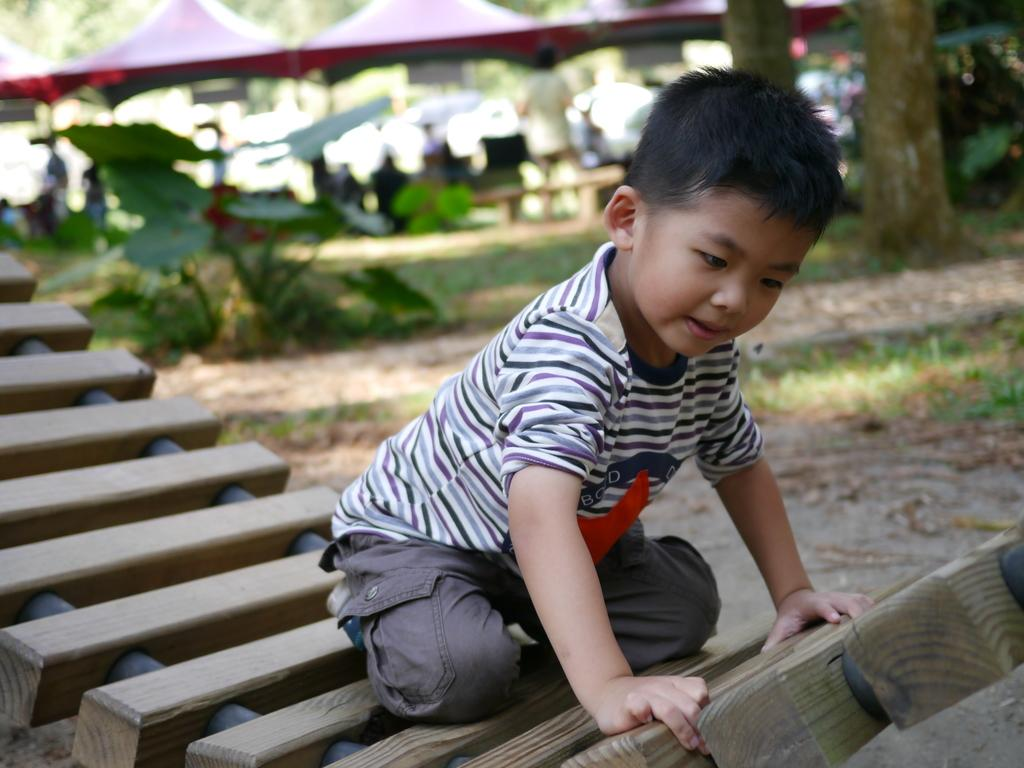Who is the main subject in the image? There is a boy in the image. What is the boy sitting on? The boy is sitting on a wooden object. What type of clothing is the boy wearing? The boy is wearing a t-shirt and pants. What can be seen in the background of the image? There are trees and grass in the background of the image. What type of wax is visible on the boy's t-shirt in the image? There is no wax visible on the boy's t-shirt in the image. What type of earth can be seen in the image? The image does not show any specific type of earth; it only shows a boy sitting on a wooden object and the background of trees and grass. 